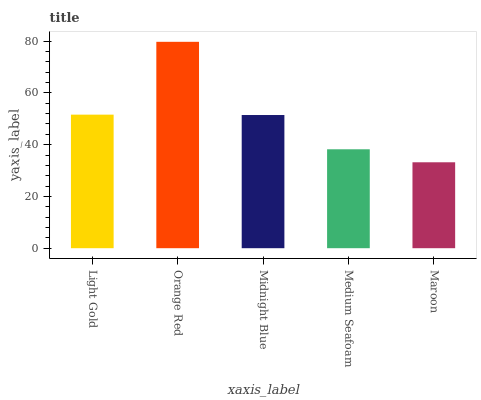Is Midnight Blue the minimum?
Answer yes or no. No. Is Midnight Blue the maximum?
Answer yes or no. No. Is Orange Red greater than Midnight Blue?
Answer yes or no. Yes. Is Midnight Blue less than Orange Red?
Answer yes or no. Yes. Is Midnight Blue greater than Orange Red?
Answer yes or no. No. Is Orange Red less than Midnight Blue?
Answer yes or no. No. Is Midnight Blue the high median?
Answer yes or no. Yes. Is Midnight Blue the low median?
Answer yes or no. Yes. Is Orange Red the high median?
Answer yes or no. No. Is Maroon the low median?
Answer yes or no. No. 